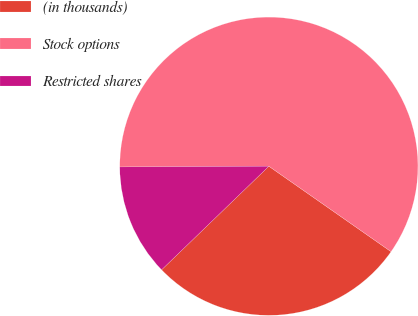Convert chart. <chart><loc_0><loc_0><loc_500><loc_500><pie_chart><fcel>(in thousands)<fcel>Stock options<fcel>Restricted shares<nl><fcel>28.07%<fcel>59.79%<fcel>12.14%<nl></chart> 